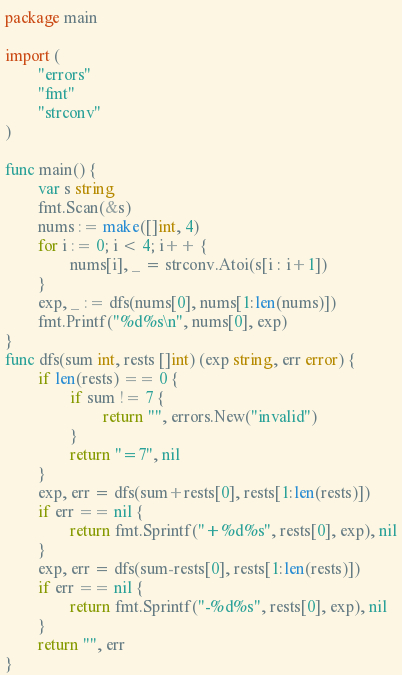<code> <loc_0><loc_0><loc_500><loc_500><_Go_>package main

import (
        "errors"
        "fmt"
        "strconv"
)

func main() {
        var s string
        fmt.Scan(&s)
        nums := make([]int, 4)
        for i := 0; i < 4; i++ {
                nums[i], _ = strconv.Atoi(s[i : i+1])
        }
        exp, _ := dfs(nums[0], nums[1:len(nums)])
        fmt.Printf("%d%s\n", nums[0], exp)
}
func dfs(sum int, rests []int) (exp string, err error) {
        if len(rests) == 0 {
                if sum != 7 {
                        return "", errors.New("invalid")
                }
                return "=7", nil
        }
        exp, err = dfs(sum+rests[0], rests[1:len(rests)])
        if err == nil {
                return fmt.Sprintf("+%d%s", rests[0], exp), nil
        }
        exp, err = dfs(sum-rests[0], rests[1:len(rests)])
        if err == nil {
                return fmt.Sprintf("-%d%s", rests[0], exp), nil
        }
        return "", err
}</code> 